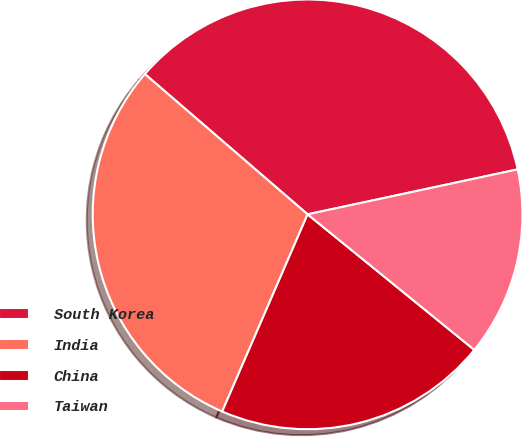Convert chart. <chart><loc_0><loc_0><loc_500><loc_500><pie_chart><fcel>South Korea<fcel>India<fcel>China<fcel>Taiwan<nl><fcel>35.32%<fcel>29.82%<fcel>20.64%<fcel>14.22%<nl></chart> 